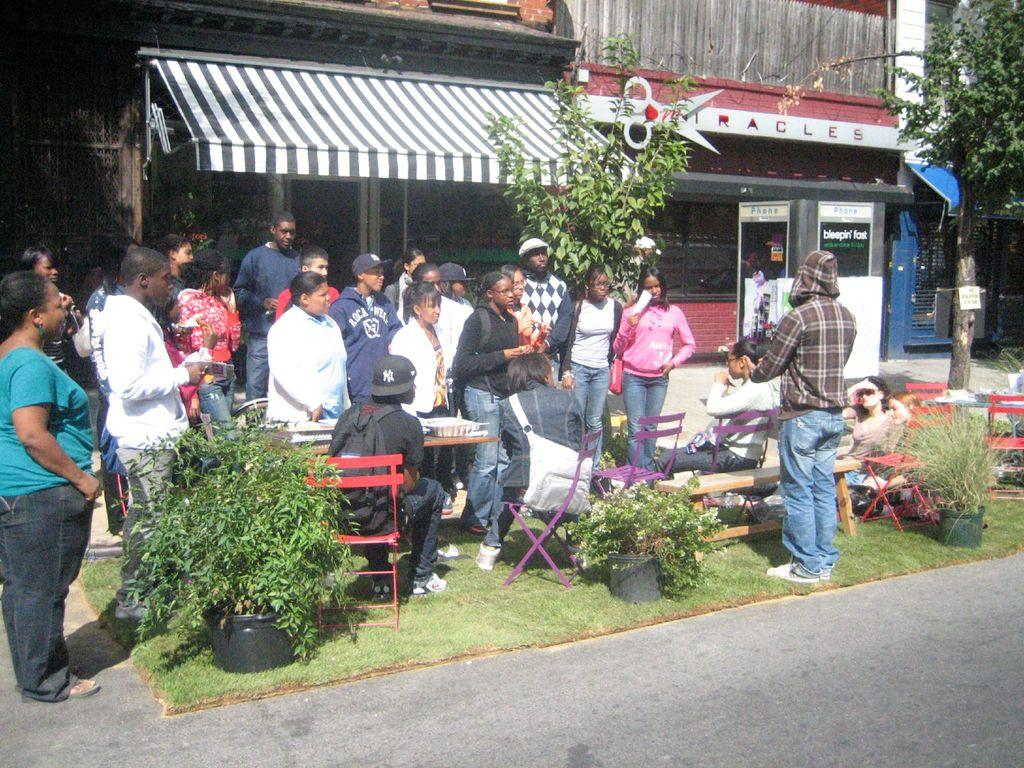What is the composition of the people in the image? There is a group of men and women in the image. How are the people positioned in relation to the boy? The group is standing in front of a boy. What might the boy be doing in the image? The boy is likely giving a speech or presentation. What can be seen in the background of the image? There are shops and a canopy shed visible in the background of the image. What type of vegetation is present in the image? There is a tree in the right corner of the image. What type of pipe is visible in the image? There is no pipe present in the image. How many plastic horses are visible in the image? There are no plastic horses present in the image. 